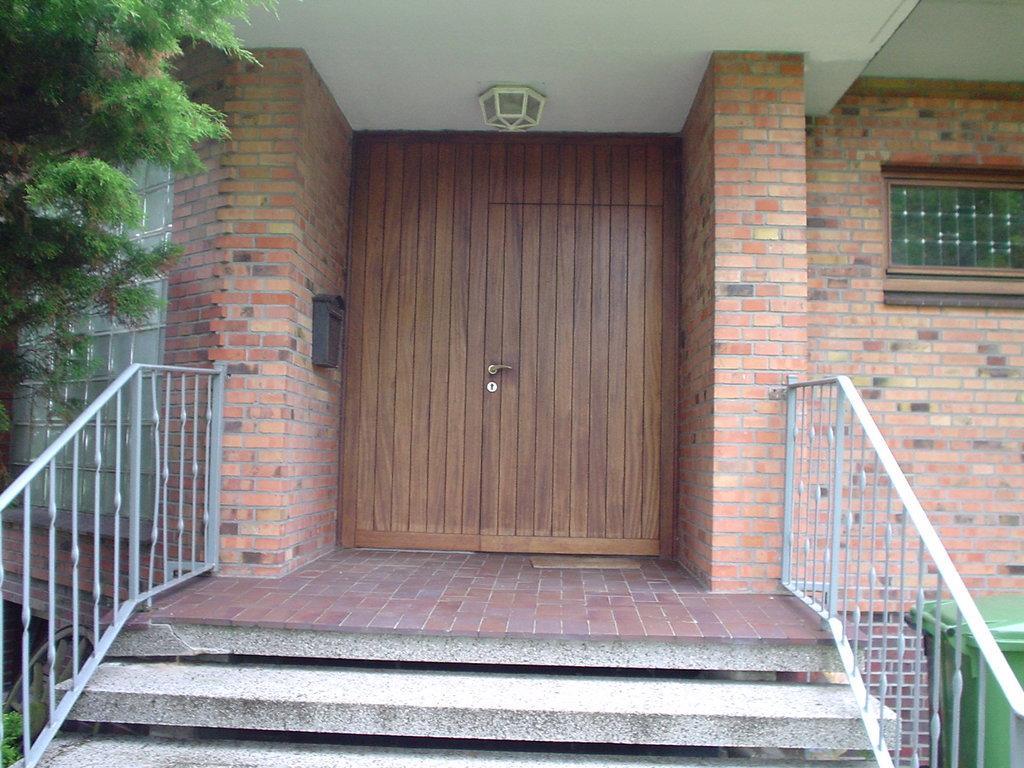Could you give a brief overview of what you see in this image? In this image i can see a wooden door,walls,dustbin,steps and trees. 